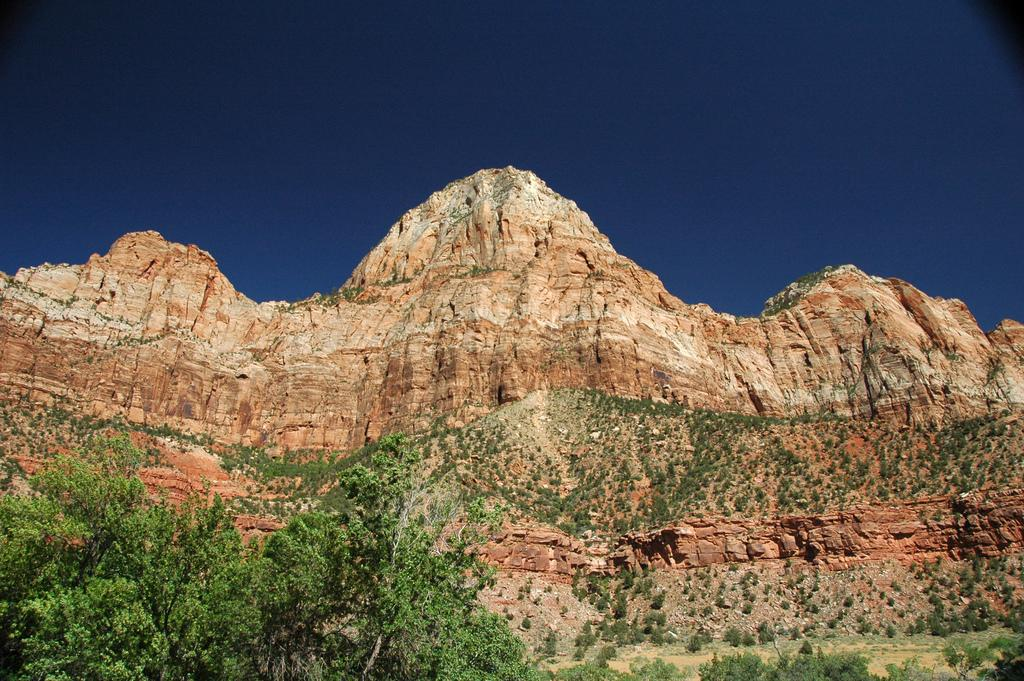What type of natural elements can be seen in the image? There are trees in the image. What type of landscape feature is visible in the background of the image? There are mountains in the background of the image. What part of the natural environment is visible in the background of the image? The sky is visible in the background of the image. What type of songs can be heard playing in the bedroom in the image? There is no bedroom or songs present in the image; it features trees, mountains, and the sky. 